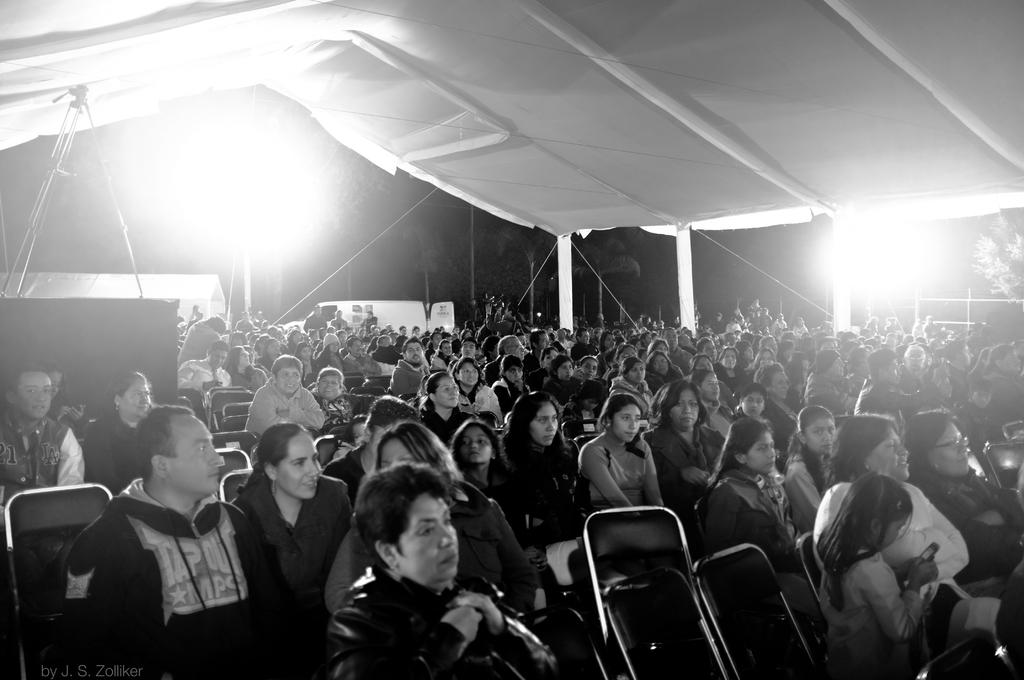What is the main subject of the image? The main subject of the image is a crowd of people. What are the people doing in the image? The people are sitting on chairs in the image. Where are the chairs located? The chairs are under a tent in the image. What can be seen in the middle of the image? There are visible light sources in the middle of the image. How many cherries are hanging from the tent in the image? There are no cherries present in the image; the chairs are under a tent with visible light sources. What type of knot is used to secure the tent in the image? There is no information about the type of knot used to secure the tent in the image. 